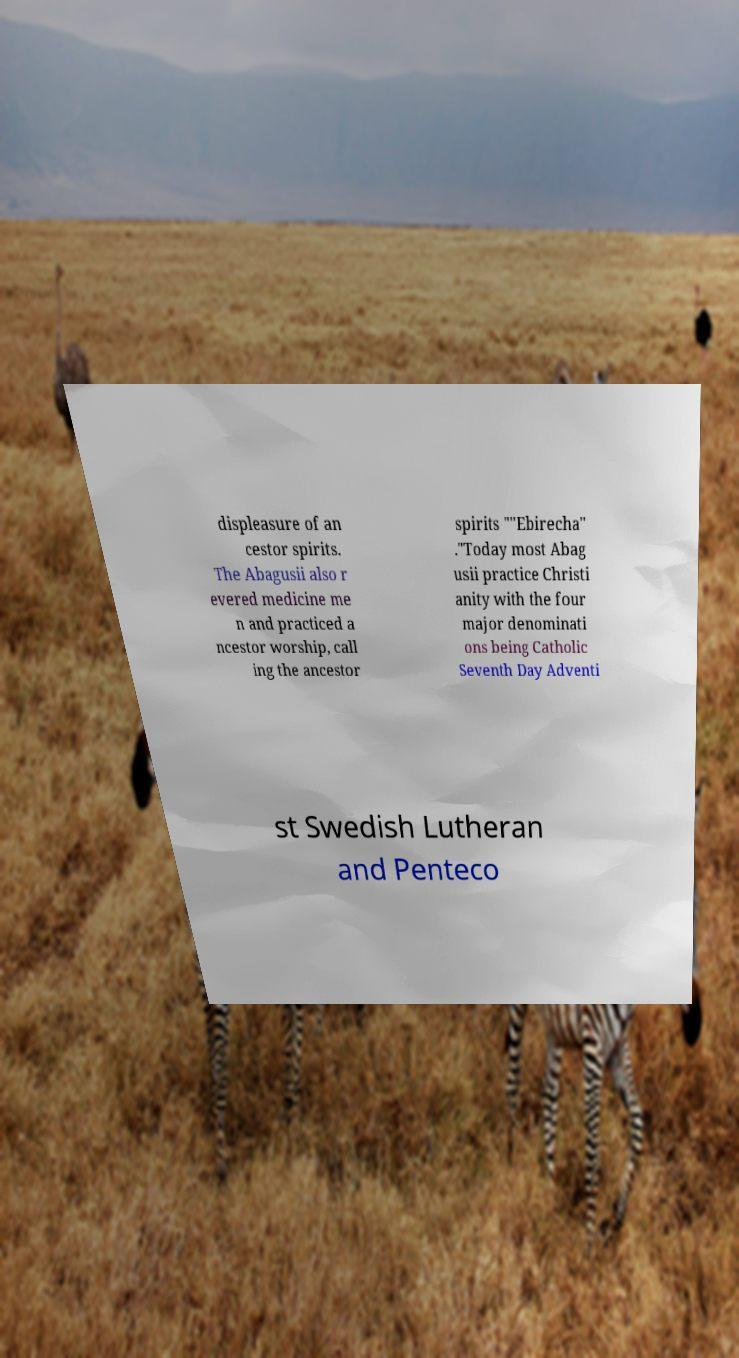Please read and relay the text visible in this image. What does it say? displeasure of an cestor spirits. The Abagusii also r evered medicine me n and practiced a ncestor worship, call ing the ancestor spirits ""Ebirecha" ."Today most Abag usii practice Christi anity with the four major denominati ons being Catholic Seventh Day Adventi st Swedish Lutheran and Penteco 